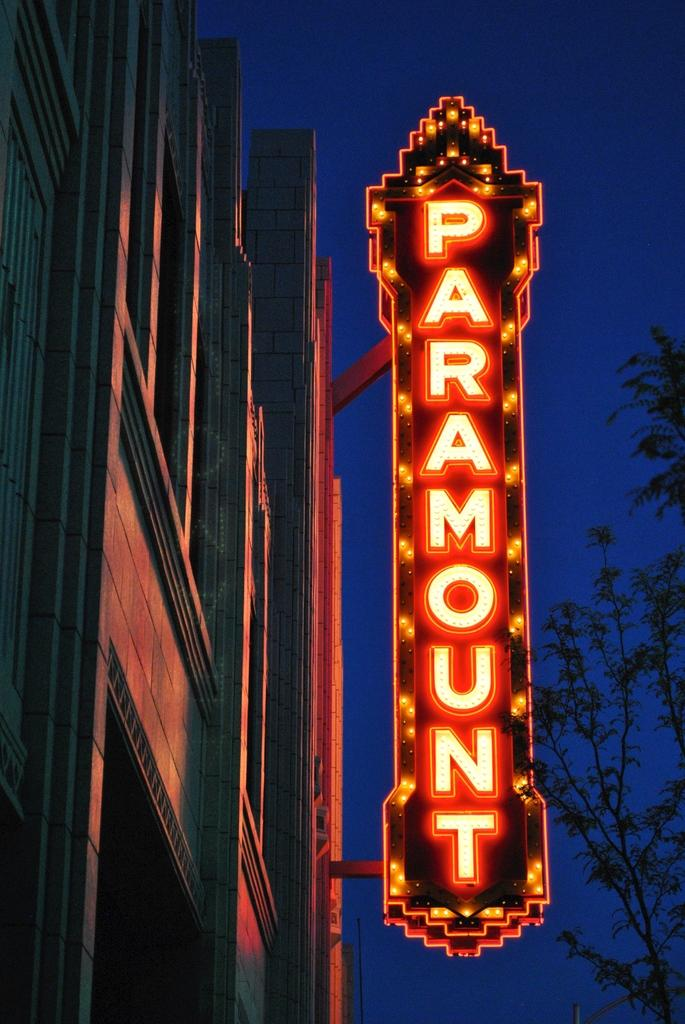What type of structure is in the image? There is a building in the image. What is attached to the building? There is a board attached to the building. What is written on the board? The name "Paramount" is written on the board. Are there any special features on the board? Yes, the board has lights. What can be seen in the background of the image? Trees and the sky are visible in the background of the image. What type of sponge is used to clean the "Paramount" sign in the image? There is no sponge visible in the image, and it is not mentioned that the sign needs cleaning. 